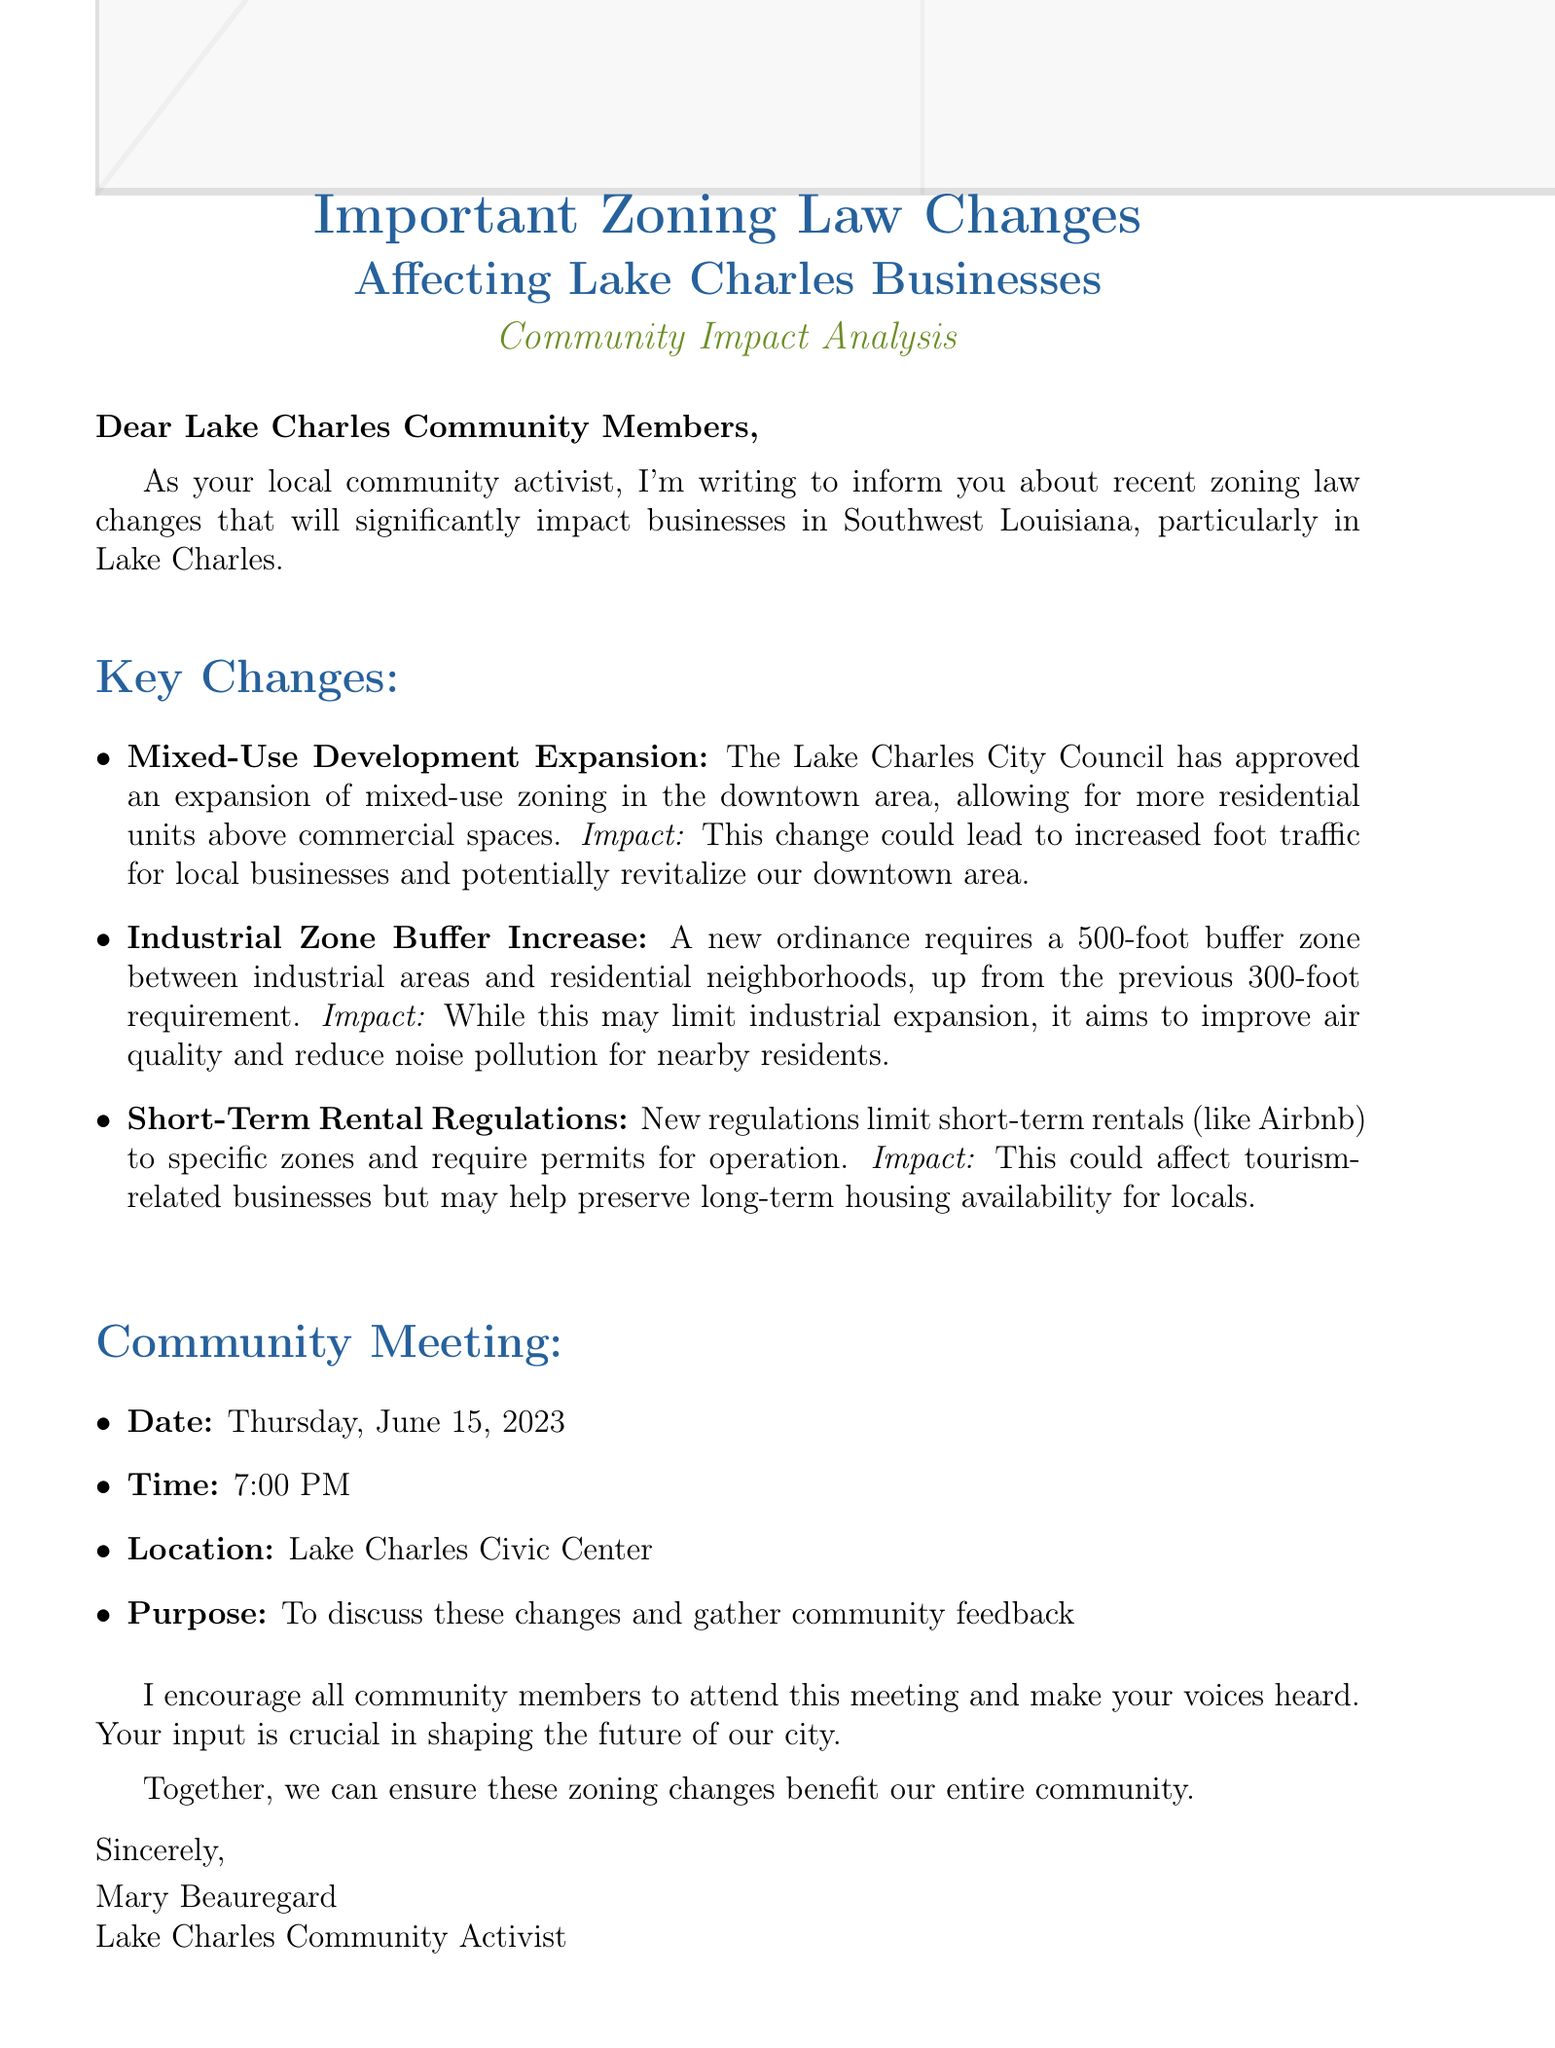What is the subject of the email? The subject expresses the main topic discussed in the email about zoning law changes.
Answer: Important Zoning Law Changes Affecting Lake Charles Businesses: Community Impact Analysis Who is the sender of the email? The sender is identified in the signature at the end of the email.
Answer: Mary Beauregard When is the community meeting scheduled? The document lists a specific date for the community meeting related to the zoning law changes.
Answer: Thursday, June 15, 2023 What is the new buffer zone requirement? The document talks about a specific measurement for buffer zones related to industrial and residential areas.
Answer: 500-foot What impact could mixed-use development expansion have? The email describes the expected consequence of the mixed-use development in terms of local business activity.
Answer: Increased foot traffic How do new regulations on short-term rentals potentially affect local housing? The reasoning involved concerns housing availability for locals in light of new regulations.
Answer: Preserve long-term housing availability What is the purpose of the community meeting? The email states the goal for gathering community members together for a discussion.
Answer: To discuss these changes and gather community feedback What is the time of the meeting? The document specifies the starting time for the planned community meeting.
Answer: 7:00 PM 